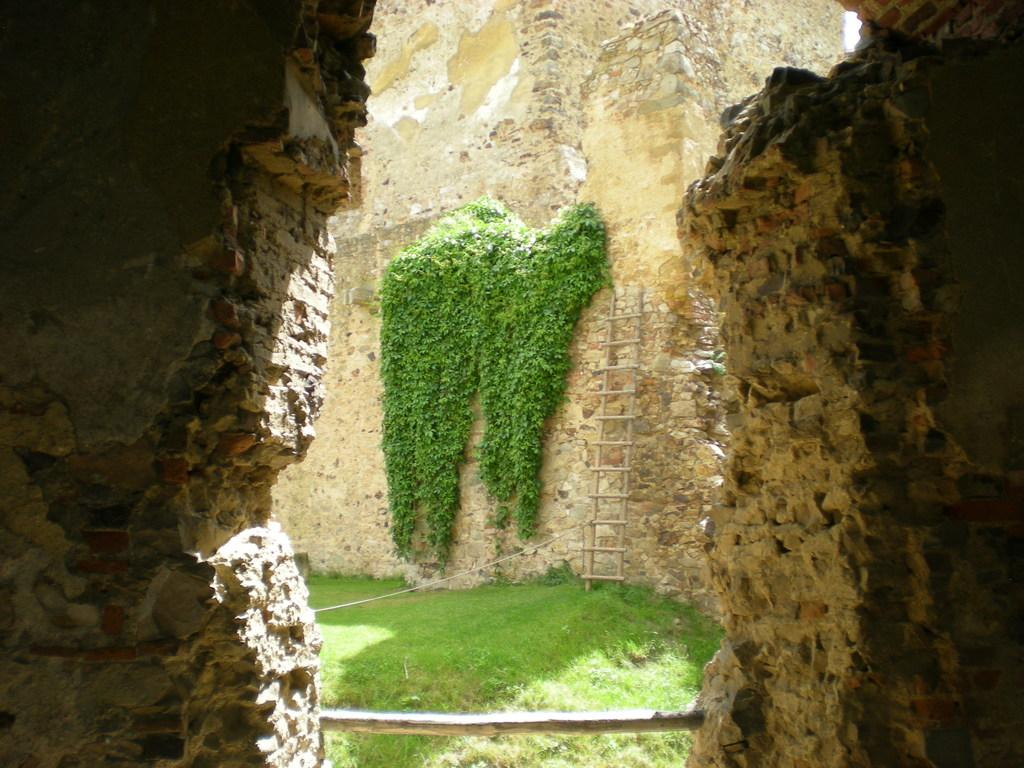What type of natural environment is depicted in the image? There is greenery in the image, suggesting a natural environment. What object is located in the center of the image? There is a ladder in the center of the image. What type of terrain is visible in the image? There are rocks around the image, indicating a rocky terrain. What type of yoke can be seen in the image? There is no yoke present in the image. What act is being performed by the rocks in the image? Rocks are inanimate objects and cannot perform acts. 